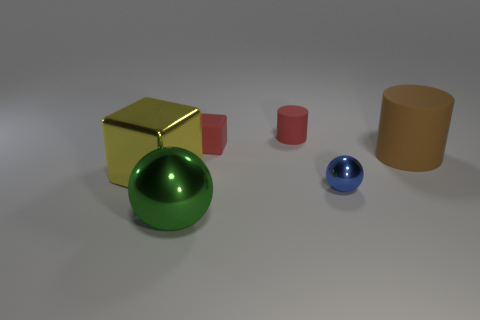There is a red cylinder that is the same size as the matte cube; what material is it?
Offer a very short reply. Rubber. There is a metal thing that is both on the right side of the metal block and to the left of the small shiny ball; what is its size?
Your response must be concise. Large. What is the color of the thing that is both right of the tiny matte cylinder and in front of the brown matte thing?
Your response must be concise. Blue. Is the number of blue metal balls on the left side of the small cube less than the number of tiny blocks in front of the tiny blue thing?
Make the answer very short. No. What number of other brown rubber objects have the same shape as the big brown rubber object?
Keep it short and to the point. 0. There is another ball that is made of the same material as the green ball; what is its size?
Your answer should be compact. Small. What color is the tiny rubber object that is right of the cube that is behind the big cube?
Your answer should be compact. Red. Is the shape of the large yellow metal object the same as the large thing that is right of the small shiny sphere?
Your answer should be very brief. No. How many red cylinders are the same size as the blue metallic ball?
Give a very brief answer. 1. There is a red thing that is the same shape as the yellow object; what is it made of?
Provide a succinct answer. Rubber. 